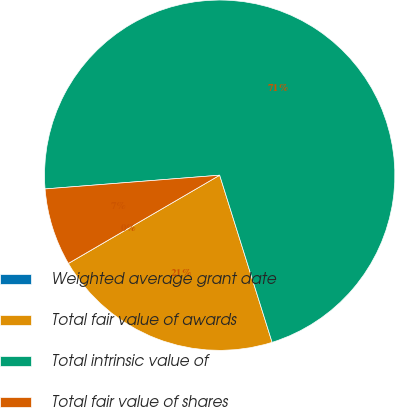<chart> <loc_0><loc_0><loc_500><loc_500><pie_chart><fcel>Weighted average grant date<fcel>Total fair value of awards<fcel>Total intrinsic value of<fcel>Total fair value of shares<nl><fcel>0.01%<fcel>21.43%<fcel>71.42%<fcel>7.15%<nl></chart> 